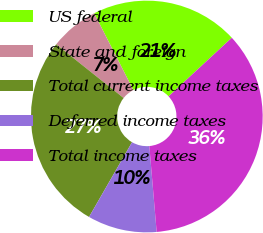<chart> <loc_0><loc_0><loc_500><loc_500><pie_chart><fcel>US federal<fcel>State and foreign<fcel>Total current income taxes<fcel>Deferred income taxes<fcel>Total income taxes<nl><fcel>20.61%<fcel>6.79%<fcel>27.4%<fcel>9.66%<fcel>35.54%<nl></chart> 